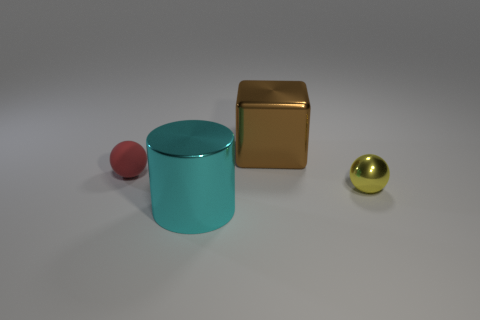Which objects in the image could roll? The spherical red ball and the cylindrical gold object appear capable of rolling due to their rounded shapes. 